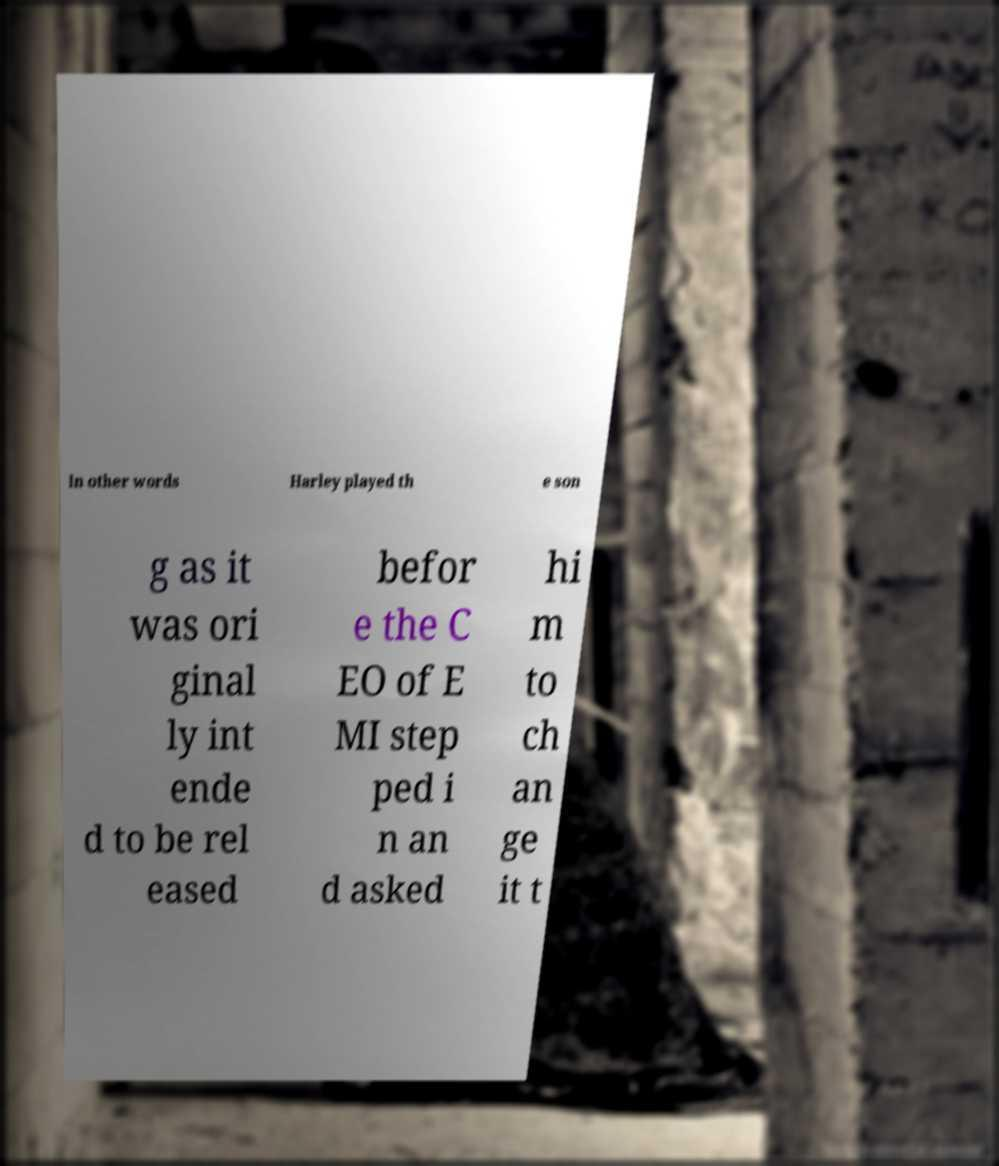Could you assist in decoding the text presented in this image and type it out clearly? In other words Harley played th e son g as it was ori ginal ly int ende d to be rel eased befor e the C EO of E MI step ped i n an d asked hi m to ch an ge it t 